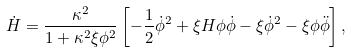Convert formula to latex. <formula><loc_0><loc_0><loc_500><loc_500>\dot { H } = \frac { \kappa ^ { 2 } } { 1 + \kappa ^ { 2 } \xi \phi ^ { 2 } } \left [ - \frac { 1 } { 2 } { \dot { \phi } } ^ { 2 } + \xi H \phi \dot { \phi } - \xi { \dot { \phi } } ^ { 2 } - \xi \phi \ddot { \phi } \right ] ,</formula> 